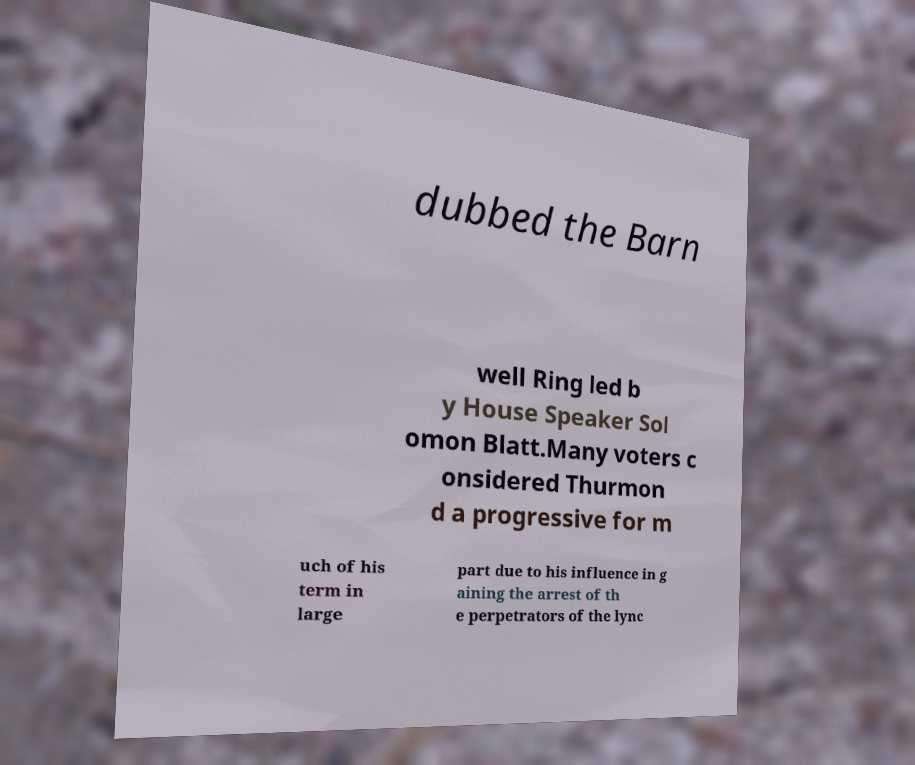There's text embedded in this image that I need extracted. Can you transcribe it verbatim? dubbed the Barn well Ring led b y House Speaker Sol omon Blatt.Many voters c onsidered Thurmon d a progressive for m uch of his term in large part due to his influence in g aining the arrest of th e perpetrators of the lync 